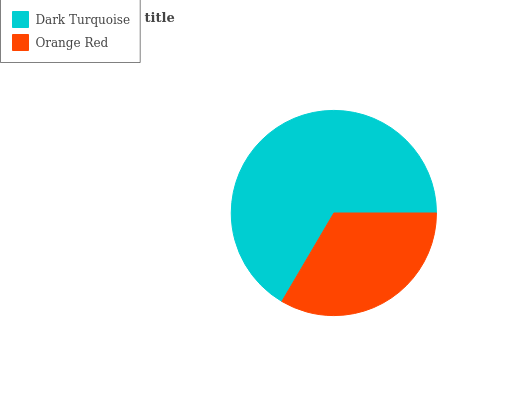Is Orange Red the minimum?
Answer yes or no. Yes. Is Dark Turquoise the maximum?
Answer yes or no. Yes. Is Orange Red the maximum?
Answer yes or no. No. Is Dark Turquoise greater than Orange Red?
Answer yes or no. Yes. Is Orange Red less than Dark Turquoise?
Answer yes or no. Yes. Is Orange Red greater than Dark Turquoise?
Answer yes or no. No. Is Dark Turquoise less than Orange Red?
Answer yes or no. No. Is Dark Turquoise the high median?
Answer yes or no. Yes. Is Orange Red the low median?
Answer yes or no. Yes. Is Orange Red the high median?
Answer yes or no. No. Is Dark Turquoise the low median?
Answer yes or no. No. 